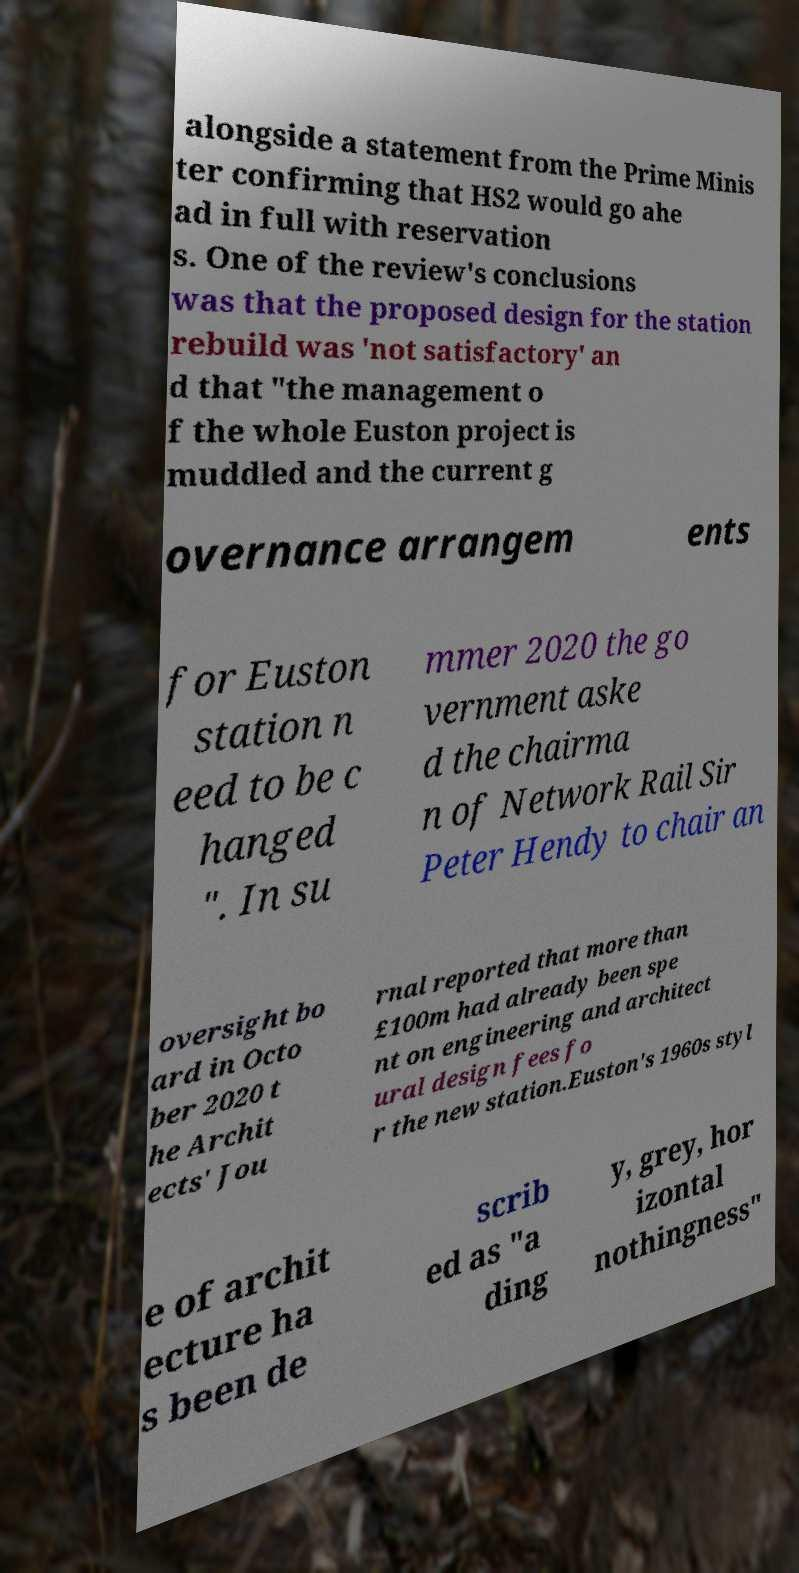Please identify and transcribe the text found in this image. alongside a statement from the Prime Minis ter confirming that HS2 would go ahe ad in full with reservation s. One of the review's conclusions was that the proposed design for the station rebuild was 'not satisfactory' an d that "the management o f the whole Euston project is muddled and the current g overnance arrangem ents for Euston station n eed to be c hanged ". In su mmer 2020 the go vernment aske d the chairma n of Network Rail Sir Peter Hendy to chair an oversight bo ard in Octo ber 2020 t he Archit ects' Jou rnal reported that more than £100m had already been spe nt on engineering and architect ural design fees fo r the new station.Euston's 1960s styl e of archit ecture ha s been de scrib ed as "a ding y, grey, hor izontal nothingness" 